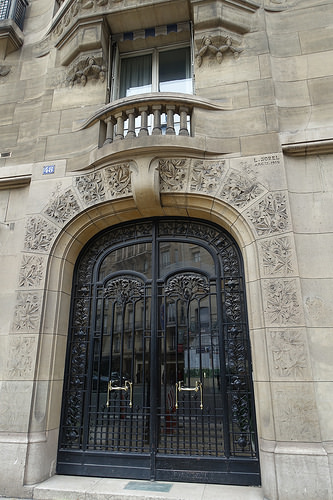<image>
Can you confirm if the door is behind the building? No. The door is not behind the building. From this viewpoint, the door appears to be positioned elsewhere in the scene. Is there a balcony in front of the entry? No. The balcony is not in front of the entry. The spatial positioning shows a different relationship between these objects. 